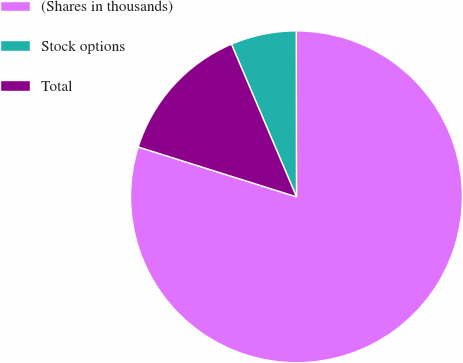<chart> <loc_0><loc_0><loc_500><loc_500><pie_chart><fcel>(Shares in thousands)<fcel>Stock options<fcel>Total<nl><fcel>79.88%<fcel>6.39%<fcel>13.73%<nl></chart> 